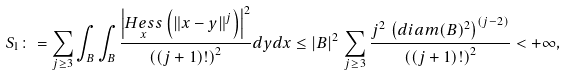Convert formula to latex. <formula><loc_0><loc_0><loc_500><loc_500>S _ { 1 } \colon = \sum _ { j \geq 3 } \int _ { B } \int _ { B } \frac { \left | \underset { x } { H e s s } \left ( \left \| x - y \right \| ^ { j } \right ) \right | ^ { 2 } } { \left ( ( j + 1 ) ! \right ) ^ { 2 } } d y d x \leq \left | B \right | ^ { 2 } \, \sum _ { j \geq 3 } \frac { j ^ { 2 } \, \left ( d i a m ( B ) ^ { 2 } \right ) ^ { ( j - 2 ) } } { \left ( ( j + 1 ) ! \right ) ^ { 2 } } < + \infty ,</formula> 